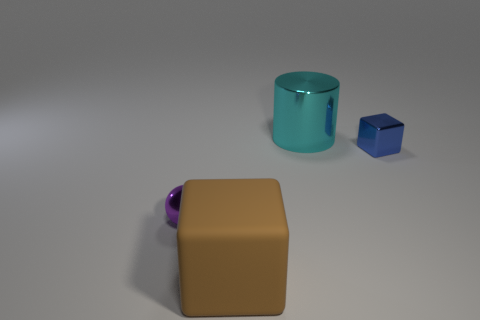Add 4 purple objects. How many objects exist? 8 Subtract all spheres. How many objects are left? 3 Subtract all metallic cylinders. Subtract all big cyan metallic things. How many objects are left? 2 Add 1 spheres. How many spheres are left? 2 Add 3 tiny purple objects. How many tiny purple objects exist? 4 Subtract 0 yellow cubes. How many objects are left? 4 